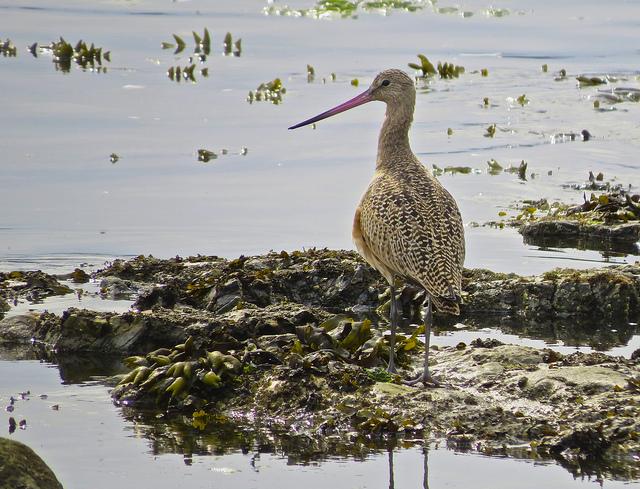What is this bird called?
Short answer required. Stork. Are there lily pads on the water?
Answer briefly. No. Is this a big bird?
Be succinct. Yes. In what type of environment does the bird live?
Short answer required. Swamp. What type of animal is this?
Give a very brief answer. Bird. What is the bird looking at?
Write a very short answer. Water. 